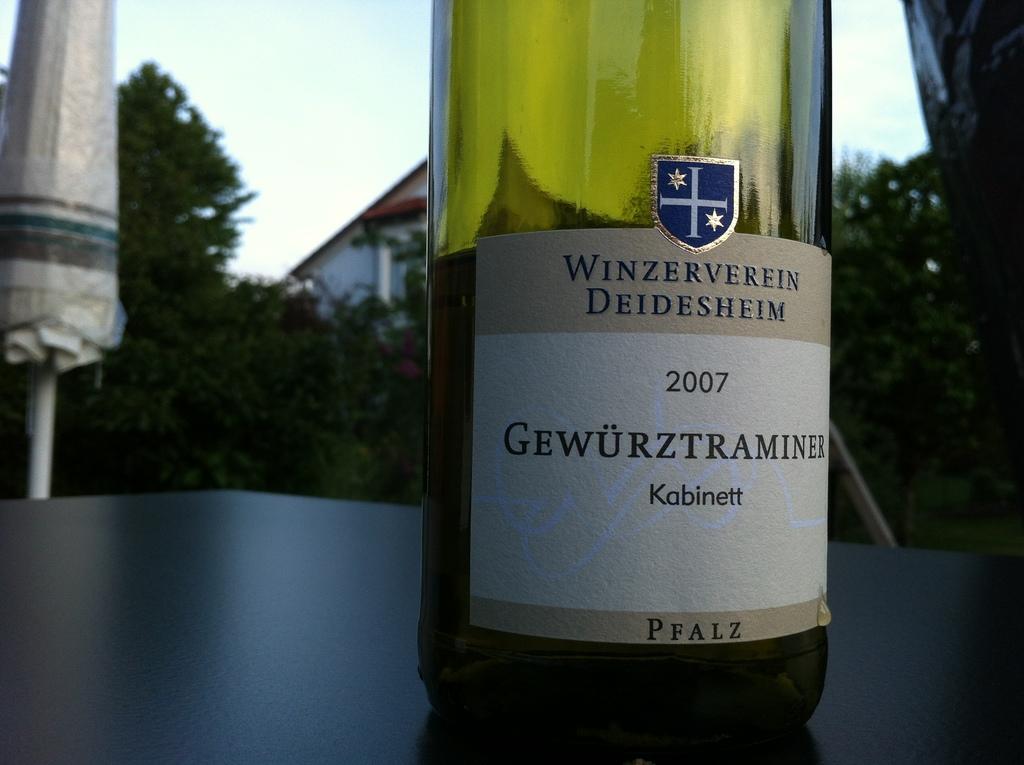What is the top word on the label?
Keep it short and to the point. Winzerverein. 